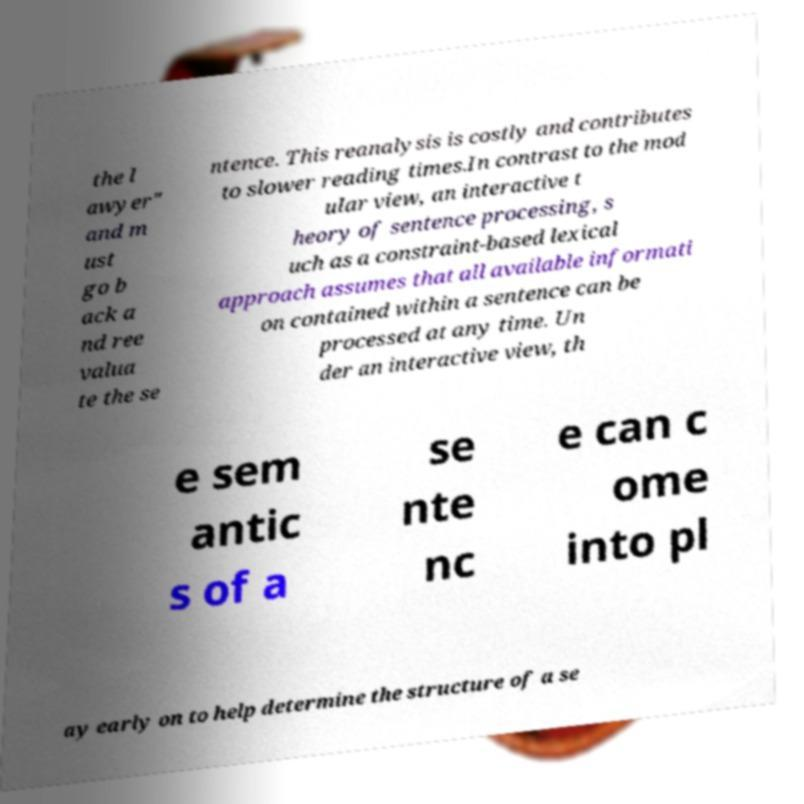Please identify and transcribe the text found in this image. the l awyer" and m ust go b ack a nd ree valua te the se ntence. This reanalysis is costly and contributes to slower reading times.In contrast to the mod ular view, an interactive t heory of sentence processing, s uch as a constraint-based lexical approach assumes that all available informati on contained within a sentence can be processed at any time. Un der an interactive view, th e sem antic s of a se nte nc e can c ome into pl ay early on to help determine the structure of a se 